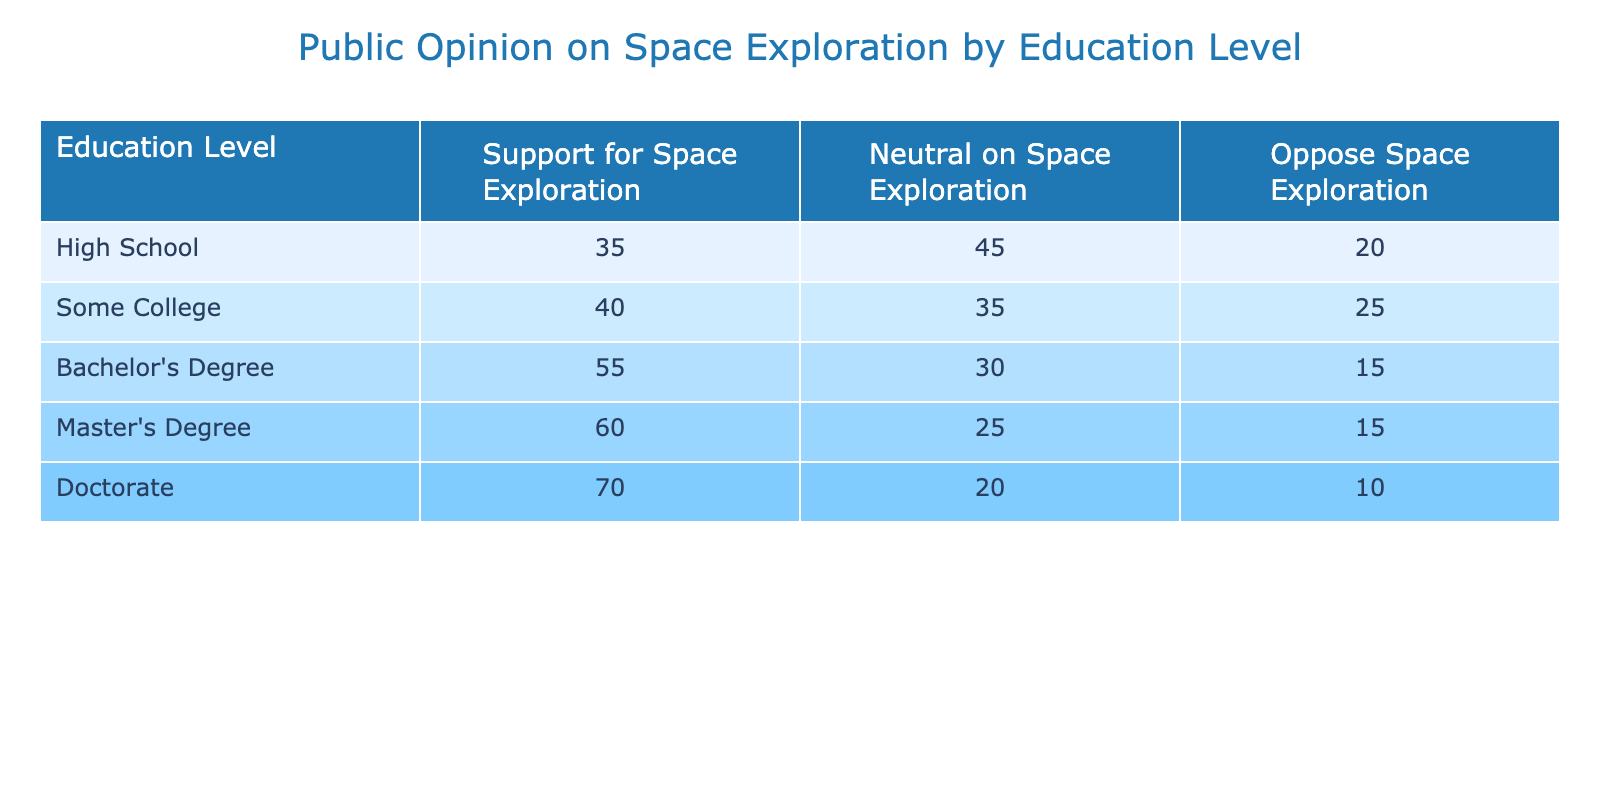What percentage of people with a Master's Degree support space exploration? The table indicates that 60% of respondents with a Master's Degree support space exploration, as it's directly listed under the "Support for Space Exploration" column for that education level.
Answer: 60% Which education level has the highest percentage of opposition to space exploration initiatives? The "Oppose Space Exploration" column shows a breakdown of opposition by education level. The highest percentage is 20% for both High School and Some College, making them the levels with the highest opposition.
Answer: High School and Some College What is the total percentage of people with a Doctorate who are either neutral or oppose space exploration? To find this total, we need to add the percentages of those who are neutral (20%) and those who oppose (10%) among those with a Doctorate. So, 20 + 10 = 30%.
Answer: 30% Is it true that more than half of individuals with a Bachelor's Degree support space exploration? In the table, it shows that 55% of individuals with a Bachelor's Degree support space exploration, which is more than half (50%). Hence, this statement is true.
Answer: Yes What is the average support for space exploration among all education levels listed in the table? To compute the average support, we add the support percentages for each education level: 35 + 40 + 55 + 60 + 70 = 260. There are 5 levels, so we divide by 5. The average is 260/5 = 52%.
Answer: 52% Which group shows a lower neutral opinion on space exploration compared to the Bachelor’s Degree group? The Bachelor’s Degree group has a neutral opinion percentage of 30%. Looking at other education levels, both Master’s Degree (25%) and Doctorate (20%) show a lower neutral opinion.
Answer: Master’s Degree and Doctorate What is the difference in support for space exploration between individuals with a Doctorate and those with a High School education? The Doctorate group supports space exploration at 70%, while the High School group supports it at 35%. The difference is 70 - 35 = 35%.
Answer: 35% How many education levels have more than 50% support for space exploration? Observing the table, the education levels with more than 50% support for space exploration are the Doctorate (70%), Master's Degree (60%), and Bachelor's Degree (55%). This counts to three education levels.
Answer: 3 What percentage of individuals with Some College are neutral on space exploration? The table indicates that 35% of individuals with Some College are neutral on space exploration, as stated in the "Neutral on Space Exploration" column for that education level.
Answer: 35% 